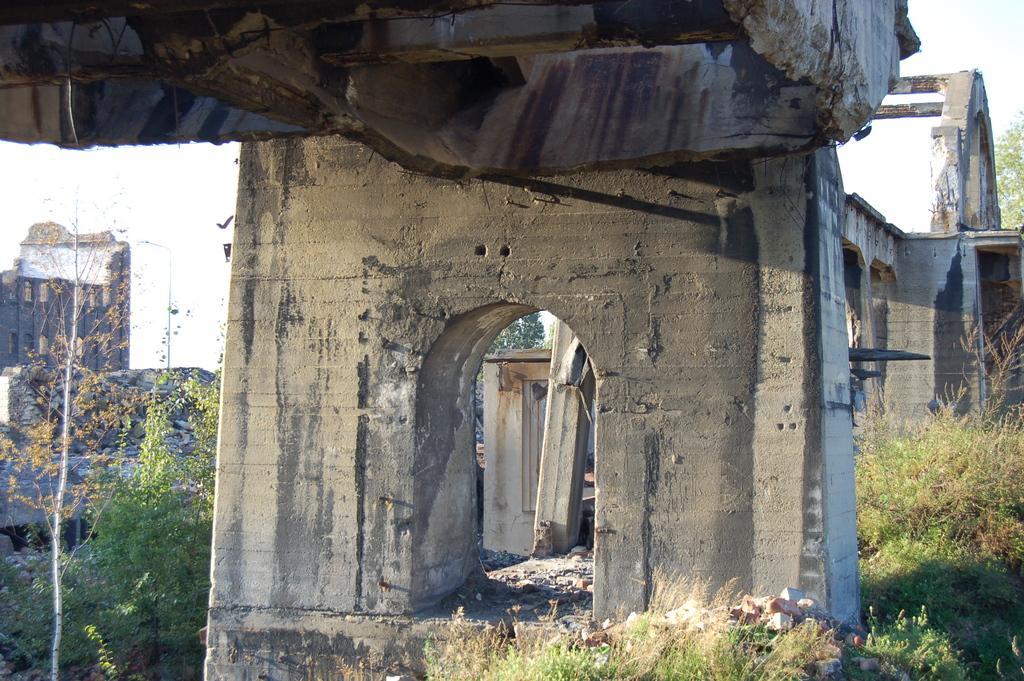Can you describe this image briefly? In this image I can see the bridge, few pillars of the bridge and few trees which are green and brown in color. In the background I can see few buildings, few trees and the sky. 